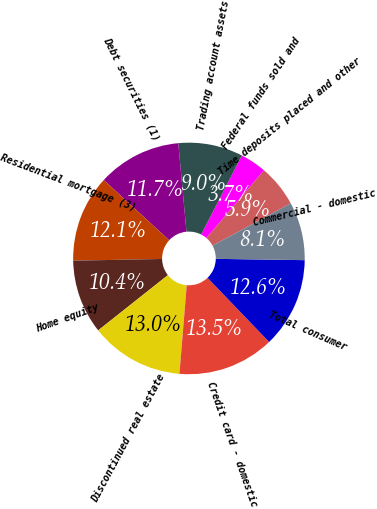Convert chart. <chart><loc_0><loc_0><loc_500><loc_500><pie_chart><fcel>Time deposits placed and other<fcel>Federal funds sold and<fcel>Trading account assets<fcel>Debt securities (1)<fcel>Residential mortgage (3)<fcel>Home equity<fcel>Discontinued real estate<fcel>Credit card - domestic<fcel>Total consumer<fcel>Commercial - domestic<nl><fcel>5.89%<fcel>3.66%<fcel>9.02%<fcel>11.7%<fcel>12.14%<fcel>10.36%<fcel>13.03%<fcel>13.48%<fcel>12.59%<fcel>8.13%<nl></chart> 